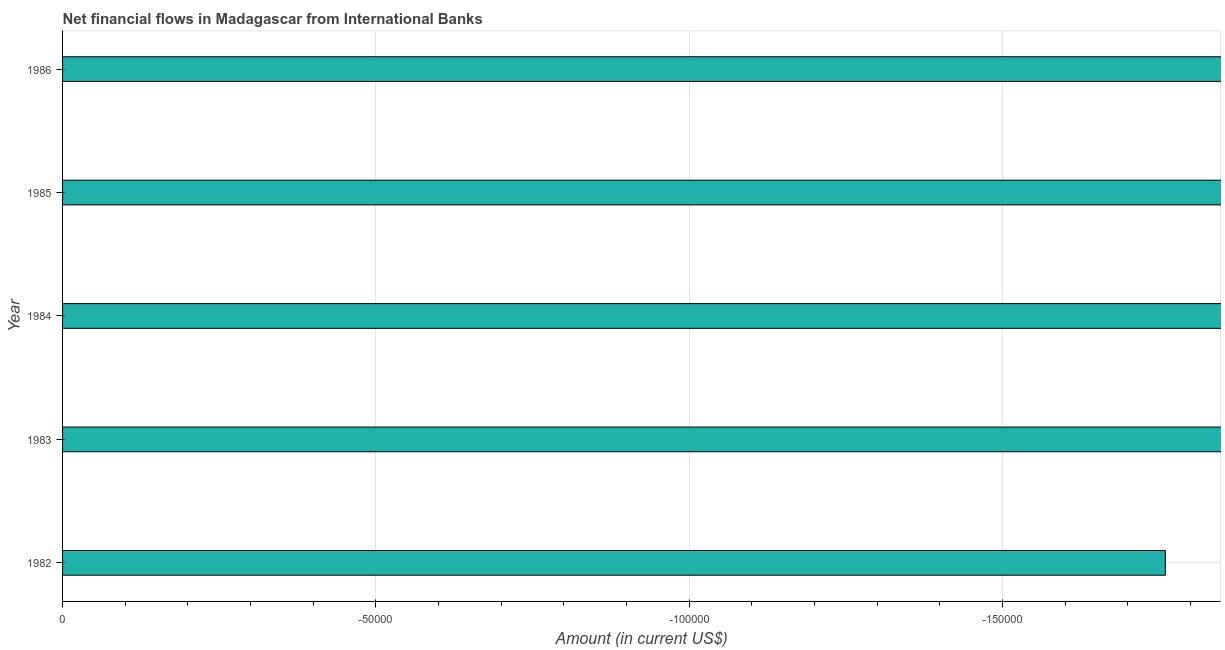What is the title of the graph?
Ensure brevity in your answer.  Net financial flows in Madagascar from International Banks. What is the net financial flows from ibrd in 1985?
Provide a succinct answer. 0. What is the median net financial flows from ibrd?
Make the answer very short. 0. Are all the bars in the graph horizontal?
Keep it short and to the point. Yes. What is the difference between two consecutive major ticks on the X-axis?
Make the answer very short. 5.00e+04. Are the values on the major ticks of X-axis written in scientific E-notation?
Offer a terse response. No. What is the Amount (in current US$) of 1983?
Your answer should be very brief. 0. What is the Amount (in current US$) of 1985?
Your response must be concise. 0. 